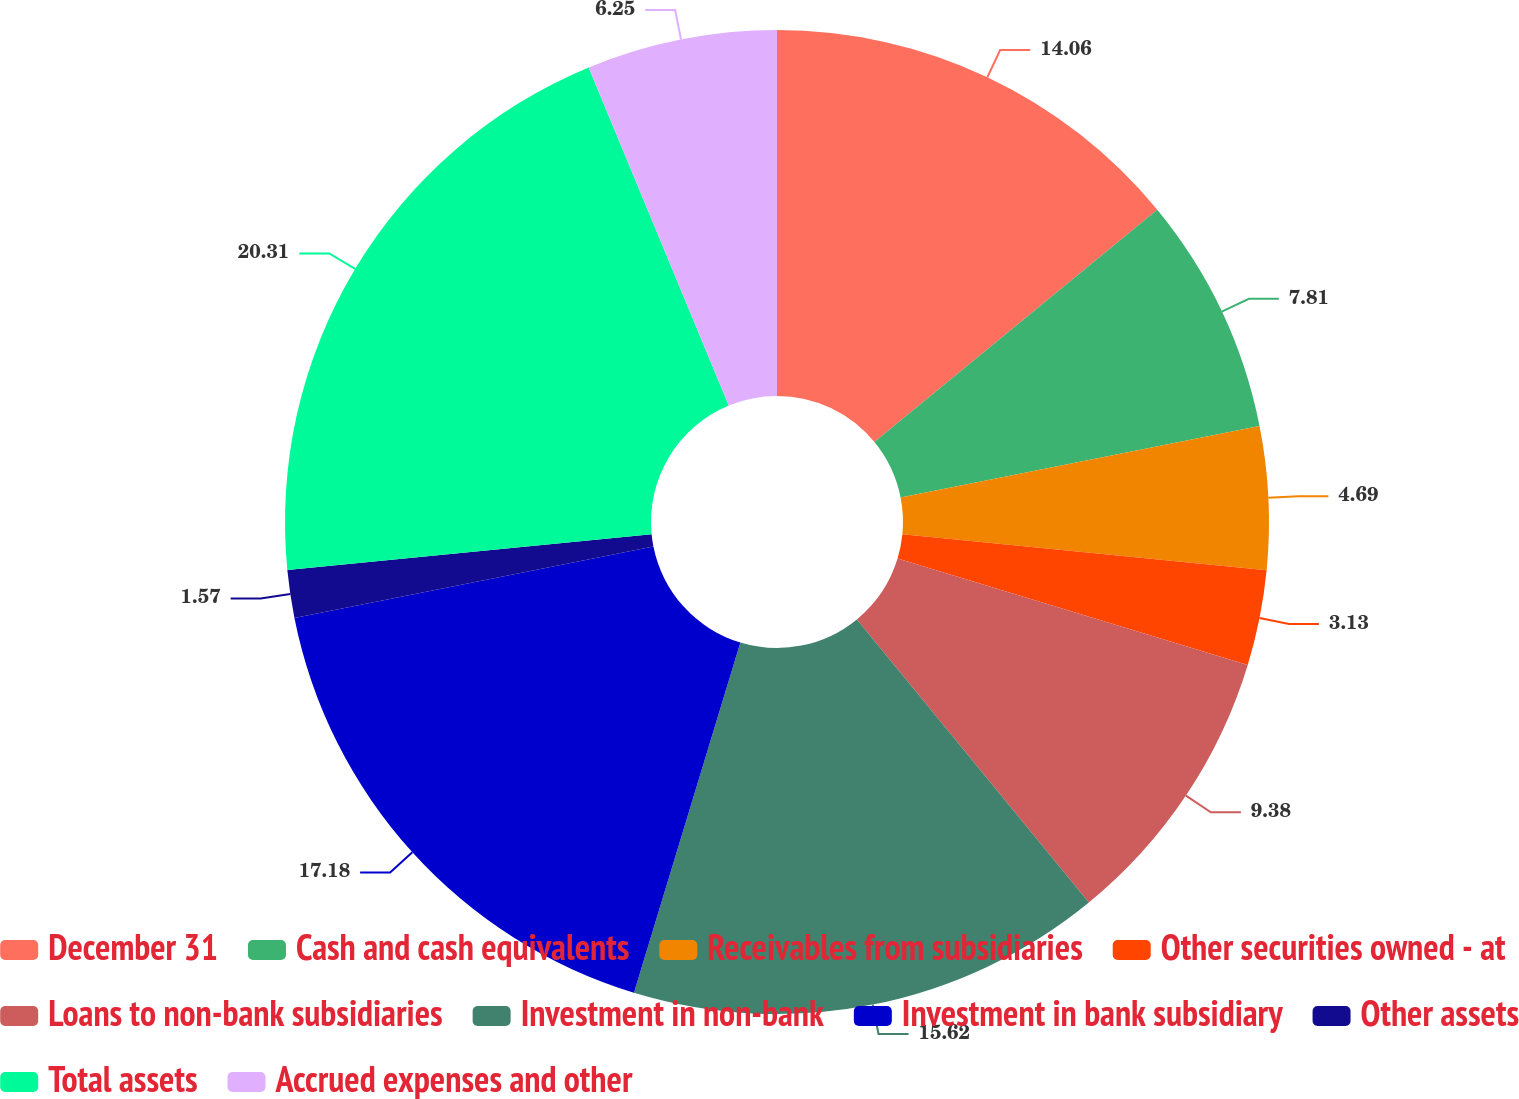<chart> <loc_0><loc_0><loc_500><loc_500><pie_chart><fcel>December 31<fcel>Cash and cash equivalents<fcel>Receivables from subsidiaries<fcel>Other securities owned - at<fcel>Loans to non-bank subsidiaries<fcel>Investment in non-bank<fcel>Investment in bank subsidiary<fcel>Other assets<fcel>Total assets<fcel>Accrued expenses and other<nl><fcel>14.06%<fcel>7.81%<fcel>4.69%<fcel>3.13%<fcel>9.38%<fcel>15.62%<fcel>17.18%<fcel>1.57%<fcel>20.3%<fcel>6.25%<nl></chart> 